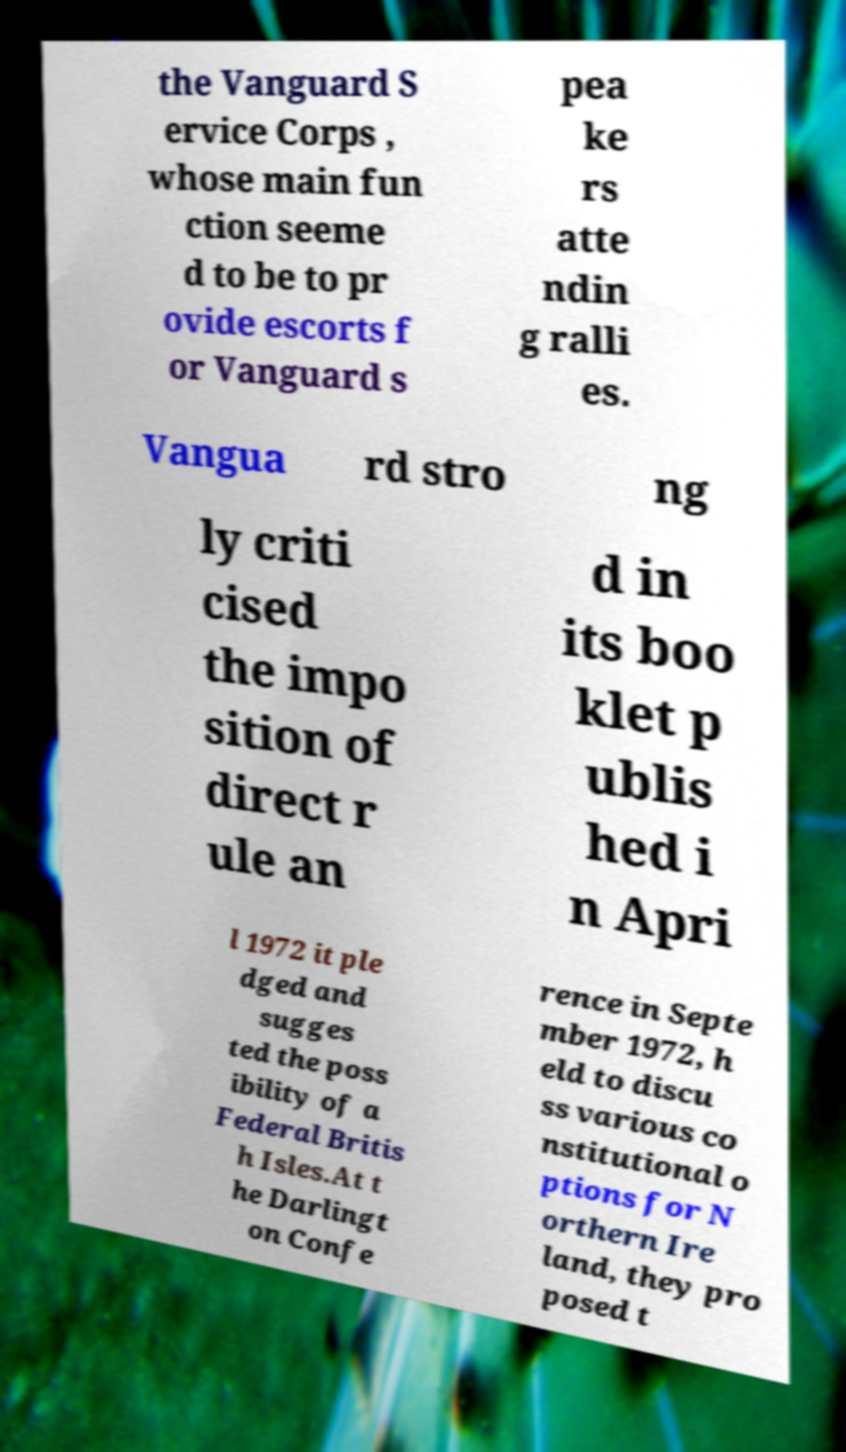Can you accurately transcribe the text from the provided image for me? the Vanguard S ervice Corps , whose main fun ction seeme d to be to pr ovide escorts f or Vanguard s pea ke rs atte ndin g ralli es. Vangua rd stro ng ly criti cised the impo sition of direct r ule an d in its boo klet p ublis hed i n Apri l 1972 it ple dged and sugges ted the poss ibility of a Federal Britis h Isles.At t he Darlingt on Confe rence in Septe mber 1972, h eld to discu ss various co nstitutional o ptions for N orthern Ire land, they pro posed t 